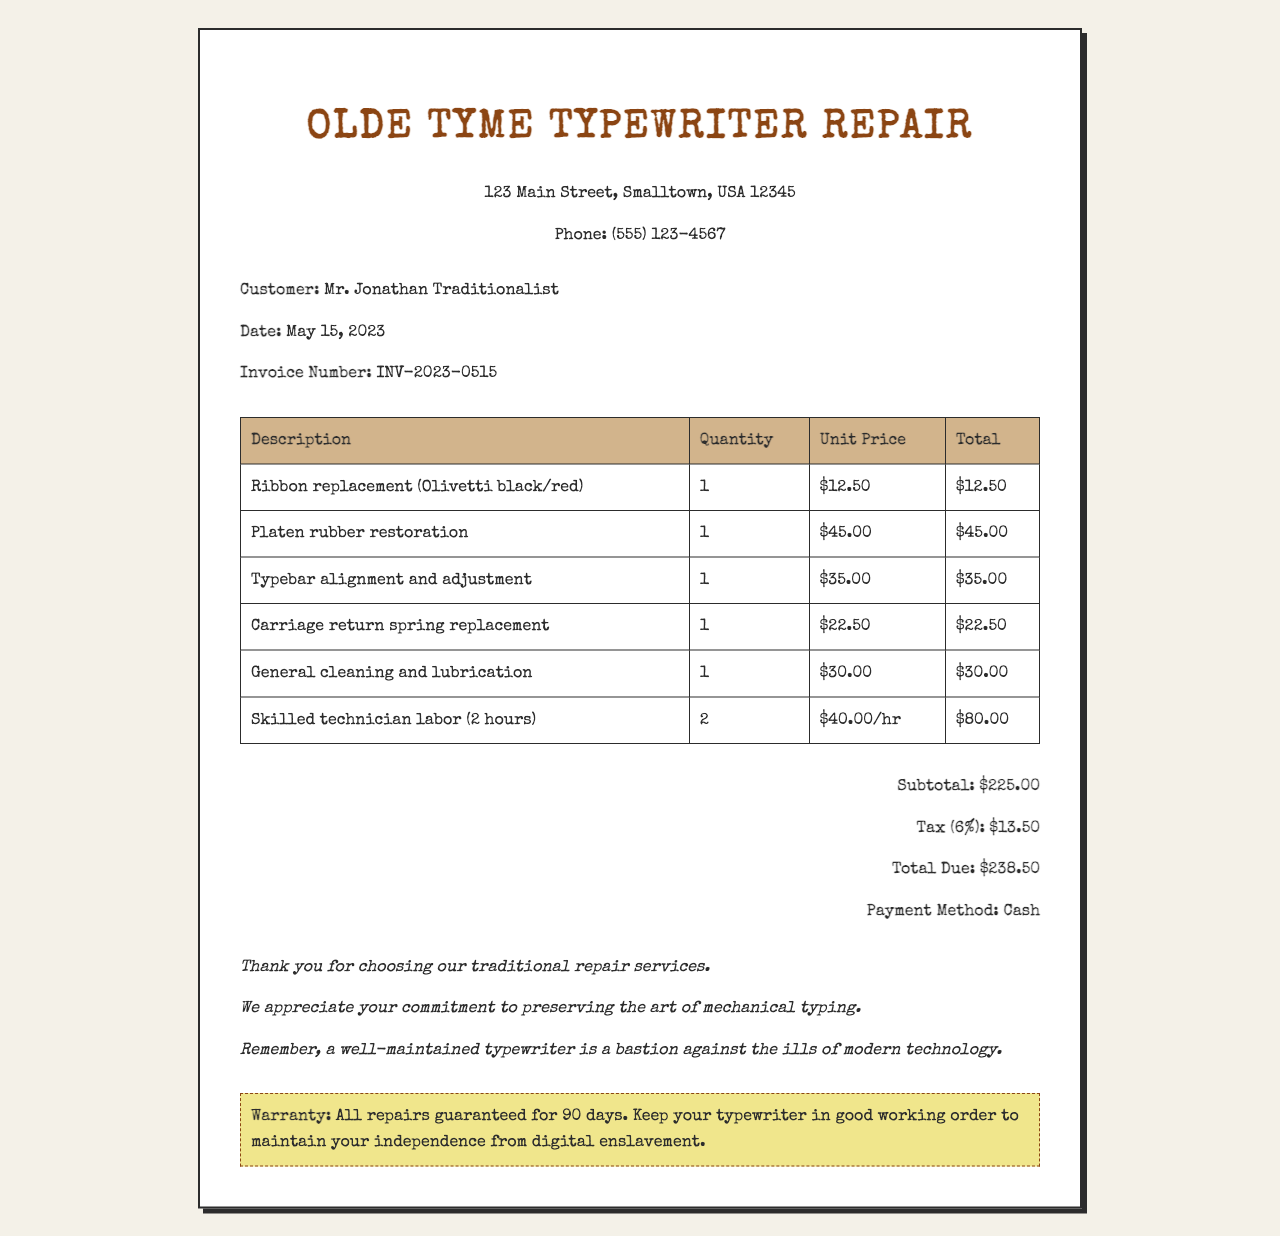What is the business name? The business name appears at the top of the document as part of the header.
Answer: Olde Tyme Typewriter Repair What was the invoice number? The invoice number is specified clearly in the customer information section of the document.
Answer: INV-2023-0515 What is the total due amount? The total due is calculated at the end of the document, showing the overall amount required to be paid.
Answer: $238.50 How much was charged for labor? The labor cost is detailed in the table of items, specifically stating its total amount.
Answer: $80.00 What item had the highest cost? The items listed provide their individual costs, where the highest can be determined.
Answer: Platen rubber restoration How many hours of labor were performed? The labor entry specifies the number of hours worked during the repair process.
Answer: 2 What is the tax rate applied? The tax percentage applied to the subtotal is noted in the total calculations section.
Answer: 6% What type of payment was used? The payment method is mentioned at the bottom of the receipt, indicating how the transaction was completed.
Answer: Cash What warranty is provided? The warranty details are highlighted in a specific section dedicated to customer information regarding repairs.
Answer: All repairs guaranteed for 90 days 